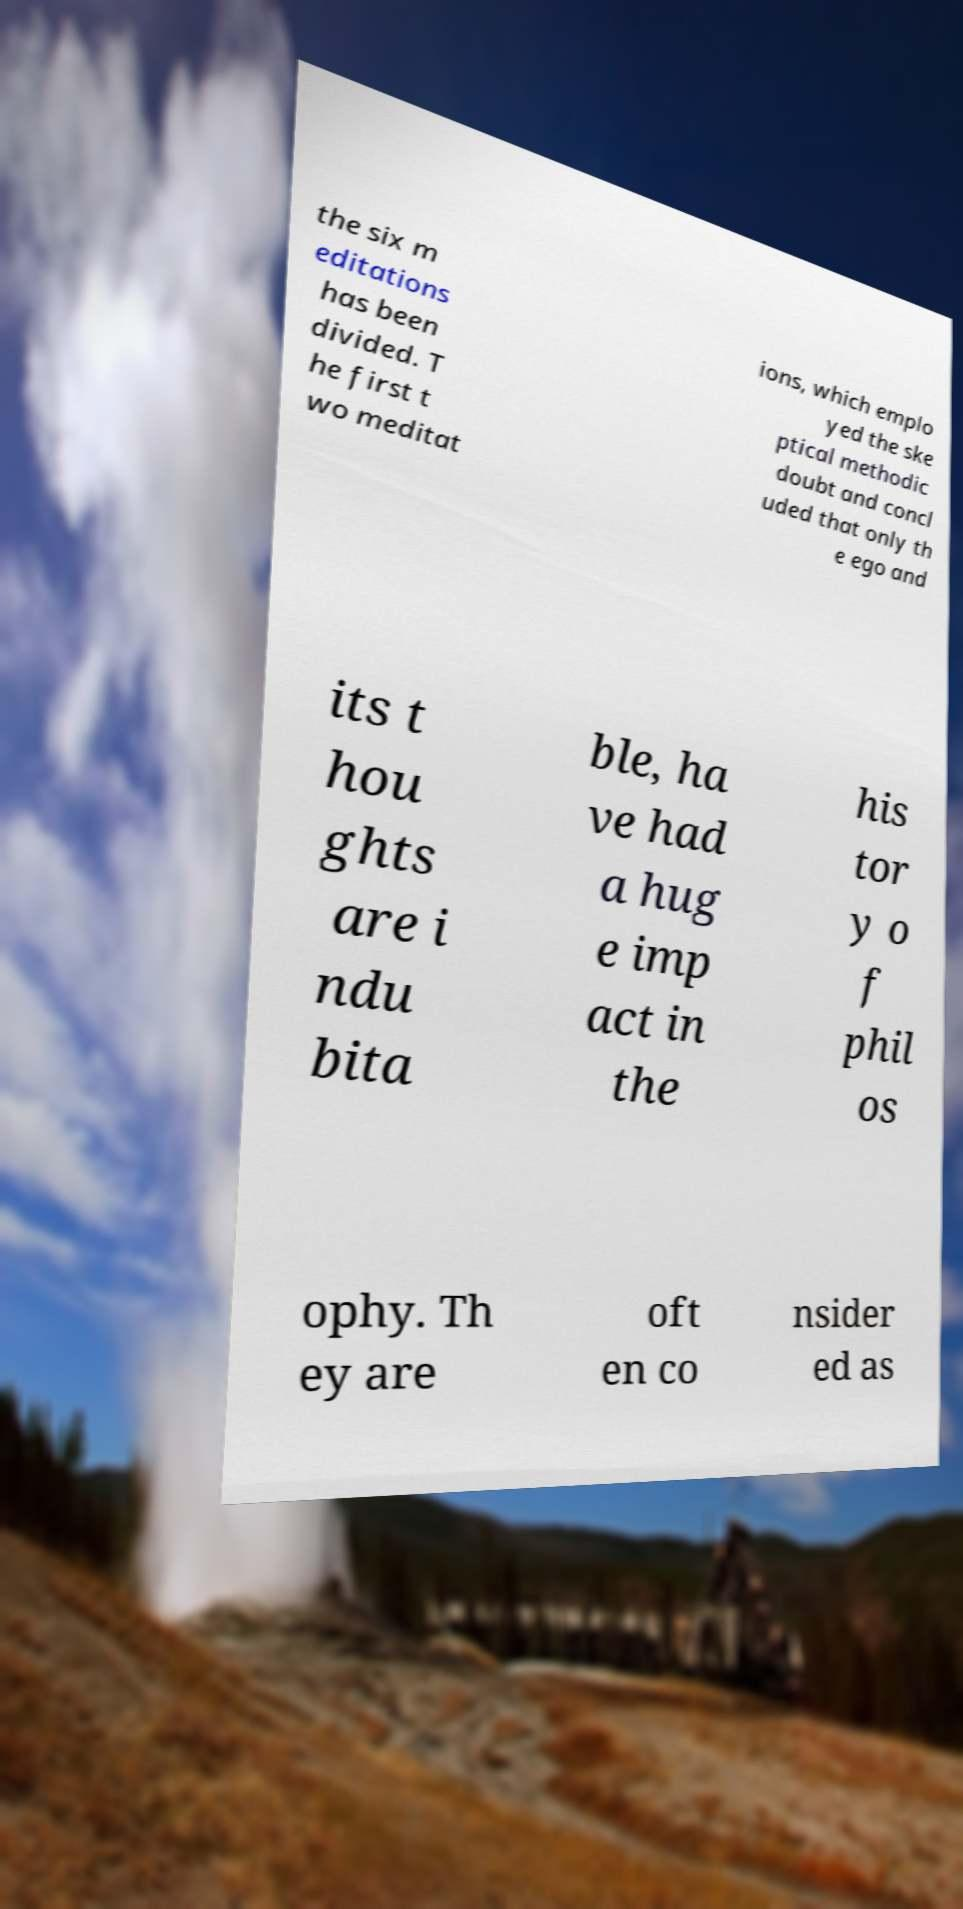Could you extract and type out the text from this image? the six m editations has been divided. T he first t wo meditat ions, which emplo yed the ske ptical methodic doubt and concl uded that only th e ego and its t hou ghts are i ndu bita ble, ha ve had a hug e imp act in the his tor y o f phil os ophy. Th ey are oft en co nsider ed as 